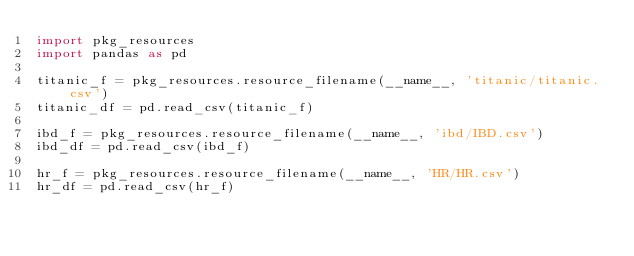<code> <loc_0><loc_0><loc_500><loc_500><_Python_>import pkg_resources
import pandas as pd

titanic_f = pkg_resources.resource_filename(__name__, 'titanic/titanic.csv')
titanic_df = pd.read_csv(titanic_f)

ibd_f = pkg_resources.resource_filename(__name__, 'ibd/IBD.csv')
ibd_df = pd.read_csv(ibd_f)

hr_f = pkg_resources.resource_filename(__name__, 'HR/HR.csv')
hr_df = pd.read_csv(hr_f)</code> 